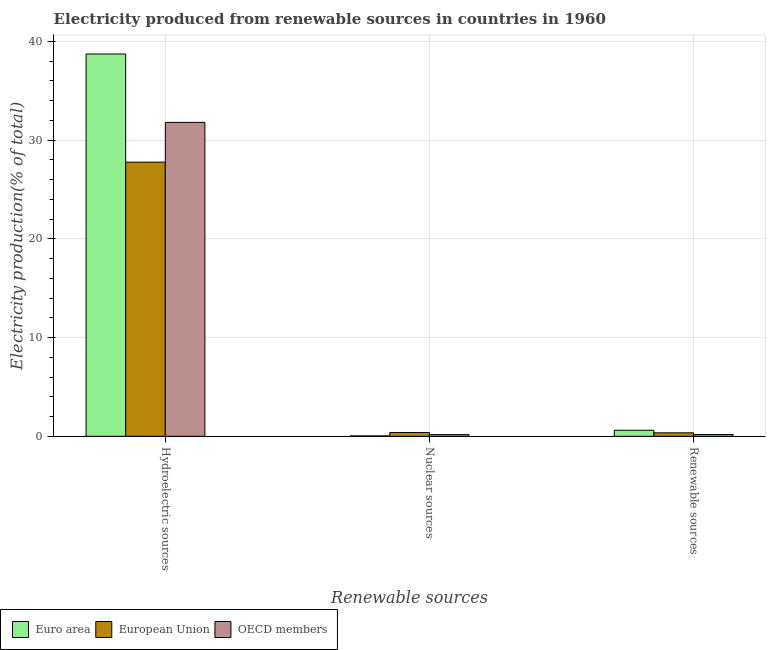How many different coloured bars are there?
Your answer should be very brief. 3. How many groups of bars are there?
Provide a short and direct response. 3. Are the number of bars on each tick of the X-axis equal?
Make the answer very short. Yes. What is the label of the 2nd group of bars from the left?
Your answer should be very brief. Nuclear sources. What is the percentage of electricity produced by nuclear sources in European Union?
Provide a succinct answer. 0.39. Across all countries, what is the maximum percentage of electricity produced by nuclear sources?
Your answer should be compact. 0.39. Across all countries, what is the minimum percentage of electricity produced by renewable sources?
Give a very brief answer. 0.18. In which country was the percentage of electricity produced by hydroelectric sources minimum?
Your response must be concise. European Union. What is the total percentage of electricity produced by nuclear sources in the graph?
Offer a very short reply. 0.6. What is the difference between the percentage of electricity produced by nuclear sources in OECD members and that in Euro area?
Provide a succinct answer. 0.13. What is the difference between the percentage of electricity produced by renewable sources in Euro area and the percentage of electricity produced by nuclear sources in OECD members?
Offer a very short reply. 0.45. What is the average percentage of electricity produced by hydroelectric sources per country?
Your response must be concise. 32.76. What is the difference between the percentage of electricity produced by hydroelectric sources and percentage of electricity produced by nuclear sources in Euro area?
Provide a short and direct response. 38.68. What is the ratio of the percentage of electricity produced by renewable sources in Euro area to that in European Union?
Make the answer very short. 1.74. Is the difference between the percentage of electricity produced by nuclear sources in Euro area and European Union greater than the difference between the percentage of electricity produced by hydroelectric sources in Euro area and European Union?
Provide a short and direct response. No. What is the difference between the highest and the second highest percentage of electricity produced by hydroelectric sources?
Your answer should be very brief. 6.93. What is the difference between the highest and the lowest percentage of electricity produced by nuclear sources?
Offer a very short reply. 0.34. What does the 3rd bar from the left in Renewable sources represents?
Ensure brevity in your answer.  OECD members. Are all the bars in the graph horizontal?
Ensure brevity in your answer.  No. Are the values on the major ticks of Y-axis written in scientific E-notation?
Keep it short and to the point. No. Does the graph contain any zero values?
Offer a very short reply. No. How many legend labels are there?
Provide a short and direct response. 3. How are the legend labels stacked?
Keep it short and to the point. Horizontal. What is the title of the graph?
Offer a very short reply. Electricity produced from renewable sources in countries in 1960. What is the label or title of the X-axis?
Offer a very short reply. Renewable sources. What is the label or title of the Y-axis?
Your response must be concise. Electricity production(% of total). What is the Electricity production(% of total) in Euro area in Hydroelectric sources?
Give a very brief answer. 38.73. What is the Electricity production(% of total) of European Union in Hydroelectric sources?
Your answer should be compact. 27.77. What is the Electricity production(% of total) in OECD members in Hydroelectric sources?
Ensure brevity in your answer.  31.8. What is the Electricity production(% of total) in Euro area in Nuclear sources?
Your response must be concise. 0.04. What is the Electricity production(% of total) of European Union in Nuclear sources?
Provide a succinct answer. 0.39. What is the Electricity production(% of total) of OECD members in Nuclear sources?
Make the answer very short. 0.17. What is the Electricity production(% of total) in Euro area in Renewable sources?
Your answer should be very brief. 0.62. What is the Electricity production(% of total) in European Union in Renewable sources?
Provide a succinct answer. 0.35. What is the Electricity production(% of total) of OECD members in Renewable sources?
Give a very brief answer. 0.18. Across all Renewable sources, what is the maximum Electricity production(% of total) in Euro area?
Your answer should be compact. 38.73. Across all Renewable sources, what is the maximum Electricity production(% of total) in European Union?
Make the answer very short. 27.77. Across all Renewable sources, what is the maximum Electricity production(% of total) of OECD members?
Provide a succinct answer. 31.8. Across all Renewable sources, what is the minimum Electricity production(% of total) in Euro area?
Your answer should be compact. 0.04. Across all Renewable sources, what is the minimum Electricity production(% of total) of European Union?
Keep it short and to the point. 0.35. Across all Renewable sources, what is the minimum Electricity production(% of total) in OECD members?
Provide a short and direct response. 0.17. What is the total Electricity production(% of total) of Euro area in the graph?
Keep it short and to the point. 39.38. What is the total Electricity production(% of total) of European Union in the graph?
Give a very brief answer. 28.51. What is the total Electricity production(% of total) of OECD members in the graph?
Keep it short and to the point. 32.14. What is the difference between the Electricity production(% of total) in Euro area in Hydroelectric sources and that in Nuclear sources?
Your answer should be compact. 38.68. What is the difference between the Electricity production(% of total) of European Union in Hydroelectric sources and that in Nuclear sources?
Make the answer very short. 27.39. What is the difference between the Electricity production(% of total) in OECD members in Hydroelectric sources and that in Nuclear sources?
Provide a short and direct response. 31.63. What is the difference between the Electricity production(% of total) in Euro area in Hydroelectric sources and that in Renewable sources?
Keep it short and to the point. 38.11. What is the difference between the Electricity production(% of total) of European Union in Hydroelectric sources and that in Renewable sources?
Give a very brief answer. 27.42. What is the difference between the Electricity production(% of total) of OECD members in Hydroelectric sources and that in Renewable sources?
Keep it short and to the point. 31.62. What is the difference between the Electricity production(% of total) of Euro area in Nuclear sources and that in Renewable sources?
Provide a short and direct response. -0.57. What is the difference between the Electricity production(% of total) in European Union in Nuclear sources and that in Renewable sources?
Your answer should be compact. 0.03. What is the difference between the Electricity production(% of total) of OECD members in Nuclear sources and that in Renewable sources?
Provide a succinct answer. -0.01. What is the difference between the Electricity production(% of total) of Euro area in Hydroelectric sources and the Electricity production(% of total) of European Union in Nuclear sources?
Offer a terse response. 38.34. What is the difference between the Electricity production(% of total) of Euro area in Hydroelectric sources and the Electricity production(% of total) of OECD members in Nuclear sources?
Your response must be concise. 38.56. What is the difference between the Electricity production(% of total) in European Union in Hydroelectric sources and the Electricity production(% of total) in OECD members in Nuclear sources?
Offer a terse response. 27.6. What is the difference between the Electricity production(% of total) in Euro area in Hydroelectric sources and the Electricity production(% of total) in European Union in Renewable sources?
Give a very brief answer. 38.37. What is the difference between the Electricity production(% of total) of Euro area in Hydroelectric sources and the Electricity production(% of total) of OECD members in Renewable sources?
Provide a short and direct response. 38.55. What is the difference between the Electricity production(% of total) of European Union in Hydroelectric sources and the Electricity production(% of total) of OECD members in Renewable sources?
Provide a short and direct response. 27.59. What is the difference between the Electricity production(% of total) of Euro area in Nuclear sources and the Electricity production(% of total) of European Union in Renewable sources?
Give a very brief answer. -0.31. What is the difference between the Electricity production(% of total) of Euro area in Nuclear sources and the Electricity production(% of total) of OECD members in Renewable sources?
Offer a very short reply. -0.14. What is the difference between the Electricity production(% of total) of European Union in Nuclear sources and the Electricity production(% of total) of OECD members in Renewable sources?
Ensure brevity in your answer.  0.21. What is the average Electricity production(% of total) of Euro area per Renewable sources?
Keep it short and to the point. 13.13. What is the average Electricity production(% of total) of European Union per Renewable sources?
Give a very brief answer. 9.5. What is the average Electricity production(% of total) of OECD members per Renewable sources?
Make the answer very short. 10.71. What is the difference between the Electricity production(% of total) in Euro area and Electricity production(% of total) in European Union in Hydroelectric sources?
Your response must be concise. 10.95. What is the difference between the Electricity production(% of total) in Euro area and Electricity production(% of total) in OECD members in Hydroelectric sources?
Keep it short and to the point. 6.93. What is the difference between the Electricity production(% of total) in European Union and Electricity production(% of total) in OECD members in Hydroelectric sources?
Keep it short and to the point. -4.03. What is the difference between the Electricity production(% of total) of Euro area and Electricity production(% of total) of European Union in Nuclear sources?
Make the answer very short. -0.34. What is the difference between the Electricity production(% of total) of Euro area and Electricity production(% of total) of OECD members in Nuclear sources?
Make the answer very short. -0.13. What is the difference between the Electricity production(% of total) of European Union and Electricity production(% of total) of OECD members in Nuclear sources?
Give a very brief answer. 0.22. What is the difference between the Electricity production(% of total) of Euro area and Electricity production(% of total) of European Union in Renewable sources?
Keep it short and to the point. 0.26. What is the difference between the Electricity production(% of total) of Euro area and Electricity production(% of total) of OECD members in Renewable sources?
Offer a very short reply. 0.44. What is the difference between the Electricity production(% of total) in European Union and Electricity production(% of total) in OECD members in Renewable sources?
Provide a short and direct response. 0.18. What is the ratio of the Electricity production(% of total) in Euro area in Hydroelectric sources to that in Nuclear sources?
Offer a very short reply. 929.7. What is the ratio of the Electricity production(% of total) of European Union in Hydroelectric sources to that in Nuclear sources?
Make the answer very short. 71.97. What is the ratio of the Electricity production(% of total) in OECD members in Hydroelectric sources to that in Nuclear sources?
Keep it short and to the point. 186.79. What is the ratio of the Electricity production(% of total) of Euro area in Hydroelectric sources to that in Renewable sources?
Offer a very short reply. 62.93. What is the ratio of the Electricity production(% of total) of European Union in Hydroelectric sources to that in Renewable sources?
Offer a terse response. 78.72. What is the ratio of the Electricity production(% of total) of OECD members in Hydroelectric sources to that in Renewable sources?
Keep it short and to the point. 179.66. What is the ratio of the Electricity production(% of total) in Euro area in Nuclear sources to that in Renewable sources?
Ensure brevity in your answer.  0.07. What is the ratio of the Electricity production(% of total) of European Union in Nuclear sources to that in Renewable sources?
Your answer should be very brief. 1.09. What is the ratio of the Electricity production(% of total) of OECD members in Nuclear sources to that in Renewable sources?
Give a very brief answer. 0.96. What is the difference between the highest and the second highest Electricity production(% of total) of Euro area?
Your response must be concise. 38.11. What is the difference between the highest and the second highest Electricity production(% of total) of European Union?
Ensure brevity in your answer.  27.39. What is the difference between the highest and the second highest Electricity production(% of total) of OECD members?
Your answer should be compact. 31.62. What is the difference between the highest and the lowest Electricity production(% of total) of Euro area?
Make the answer very short. 38.68. What is the difference between the highest and the lowest Electricity production(% of total) in European Union?
Ensure brevity in your answer.  27.42. What is the difference between the highest and the lowest Electricity production(% of total) in OECD members?
Ensure brevity in your answer.  31.63. 